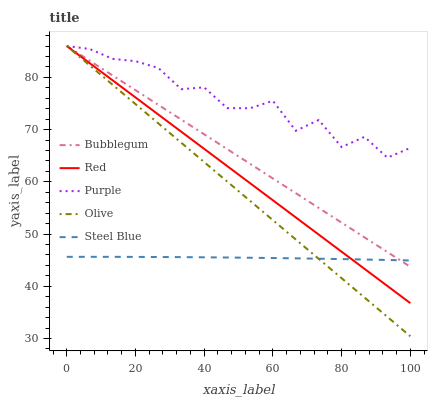Does Steel Blue have the minimum area under the curve?
Answer yes or no. Yes. Does Purple have the maximum area under the curve?
Answer yes or no. Yes. Does Olive have the minimum area under the curve?
Answer yes or no. No. Does Olive have the maximum area under the curve?
Answer yes or no. No. Is Olive the smoothest?
Answer yes or no. Yes. Is Purple the roughest?
Answer yes or no. Yes. Is Red the smoothest?
Answer yes or no. No. Is Red the roughest?
Answer yes or no. No. Does Olive have the lowest value?
Answer yes or no. Yes. Does Red have the lowest value?
Answer yes or no. No. Does Bubblegum have the highest value?
Answer yes or no. Yes. Does Steel Blue have the highest value?
Answer yes or no. No. Is Steel Blue less than Purple?
Answer yes or no. Yes. Is Purple greater than Steel Blue?
Answer yes or no. Yes. Does Red intersect Purple?
Answer yes or no. Yes. Is Red less than Purple?
Answer yes or no. No. Is Red greater than Purple?
Answer yes or no. No. Does Steel Blue intersect Purple?
Answer yes or no. No. 